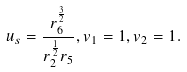Convert formula to latex. <formula><loc_0><loc_0><loc_500><loc_500>u _ { s } = \frac { r _ { 6 } ^ { \frac { 3 } { 2 } } } { r _ { 2 } ^ { \frac { 1 } { 2 } } r _ { 5 } } , v _ { 1 } = 1 , v _ { 2 } = 1 .</formula> 